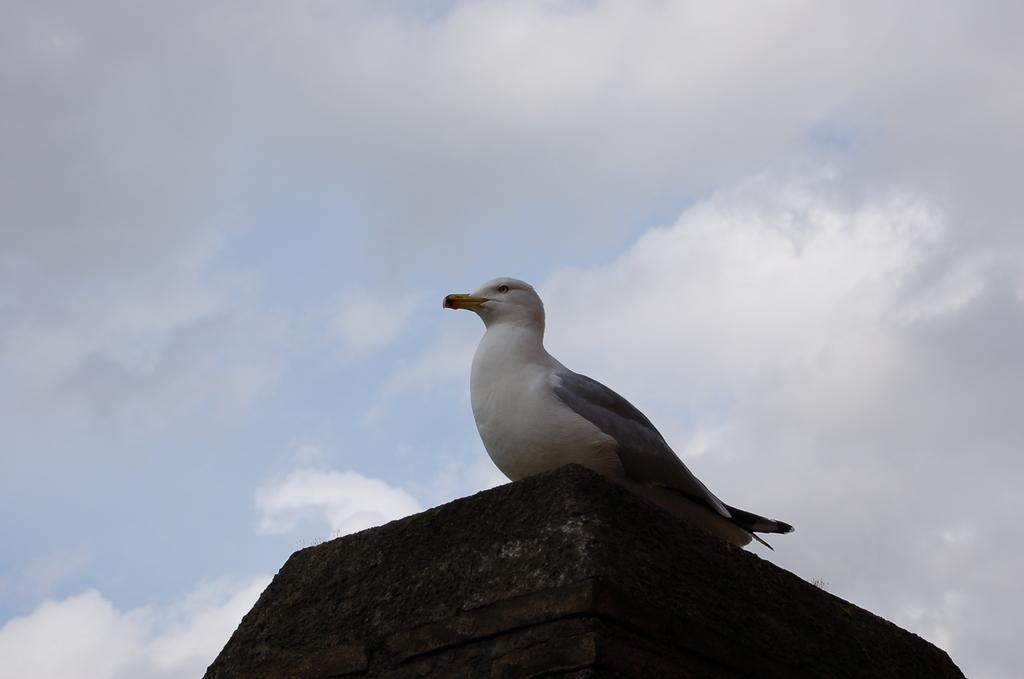What type of bird is in the image? There is a pigeon in the image. Where is the pigeon located? The pigeon is sitting on a wall. What color is the wall? The wall is black in color. What colors are the pigeon? The pigeon is in white and gray colors. What can be seen in the background of the image? There are clouds in the sky in the background of the image. Are there any trees or an ocean visible in the image? No, there are no trees or ocean visible in the image; it only features a pigeon sitting on a black wall with clouds in the sky in the background. 